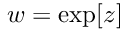<formula> <loc_0><loc_0><loc_500><loc_500>w = \exp [ z ]</formula> 